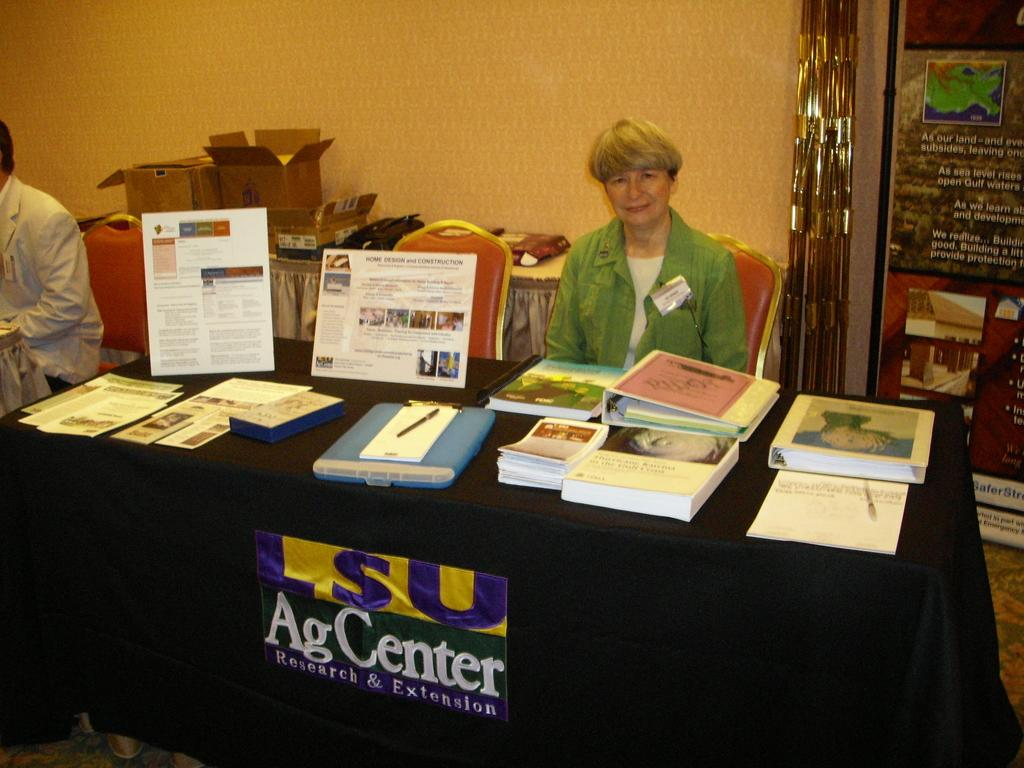<image>
Give a short and clear explanation of the subsequent image. A booth for LSU AgCenter with one woman behind. 